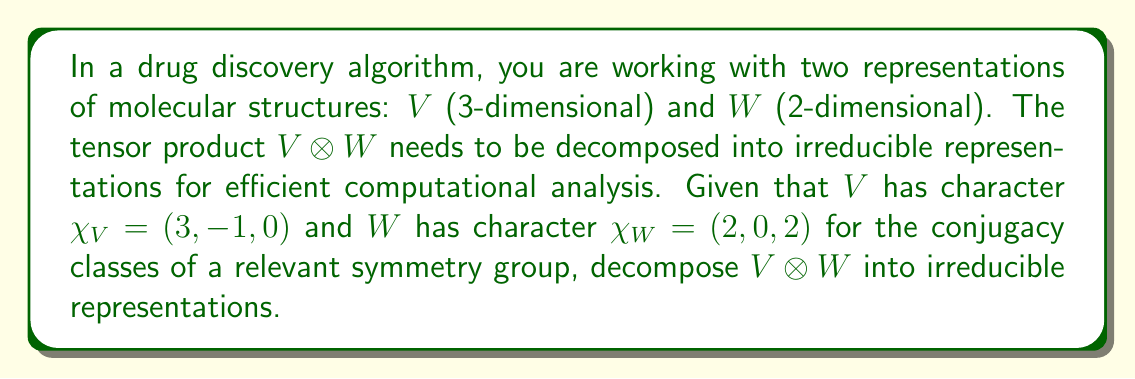Teach me how to tackle this problem. 1. Calculate the character of $V \otimes W$:
   $\chi_{V \otimes W} = \chi_V \cdot \chi_W = (3 \cdot 2, -1 \cdot 0, 0 \cdot 2) = (6, 0, 0)$

2. List the irreducible representations of the group:
   Let's assume there are three irreducible representations: $\chi_1 = (1, 1, 1)$, $\chi_2 = (1, -1, 1)$, and $\chi_3 = (2, 0, -1)$

3. Calculate the inner products of $\chi_{V \otimes W}$ with each irreducible representation:
   $\langle \chi_{V \otimes W}, \chi_1 \rangle = \frac{1}{3}(6 \cdot 1 + 0 \cdot 1 + 0 \cdot 1) = 2$
   $\langle \chi_{V \otimes W}, \chi_2 \rangle = \frac{1}{3}(6 \cdot 1 + 0 \cdot (-1) + 0 \cdot 1) = 2$
   $\langle \chi_{V \otimes W}, \chi_3 \rangle = \frac{1}{3}(6 \cdot 2 + 0 \cdot 0 + 0 \cdot (-1)) = 4$

4. The decomposition is given by the multiplicities of each irreducible representation:
   $V \otimes W = 2\chi_1 \oplus 2\chi_2 \oplus 4\chi_3$
Answer: $2\chi_1 \oplus 2\chi_2 \oplus 4\chi_3$ 